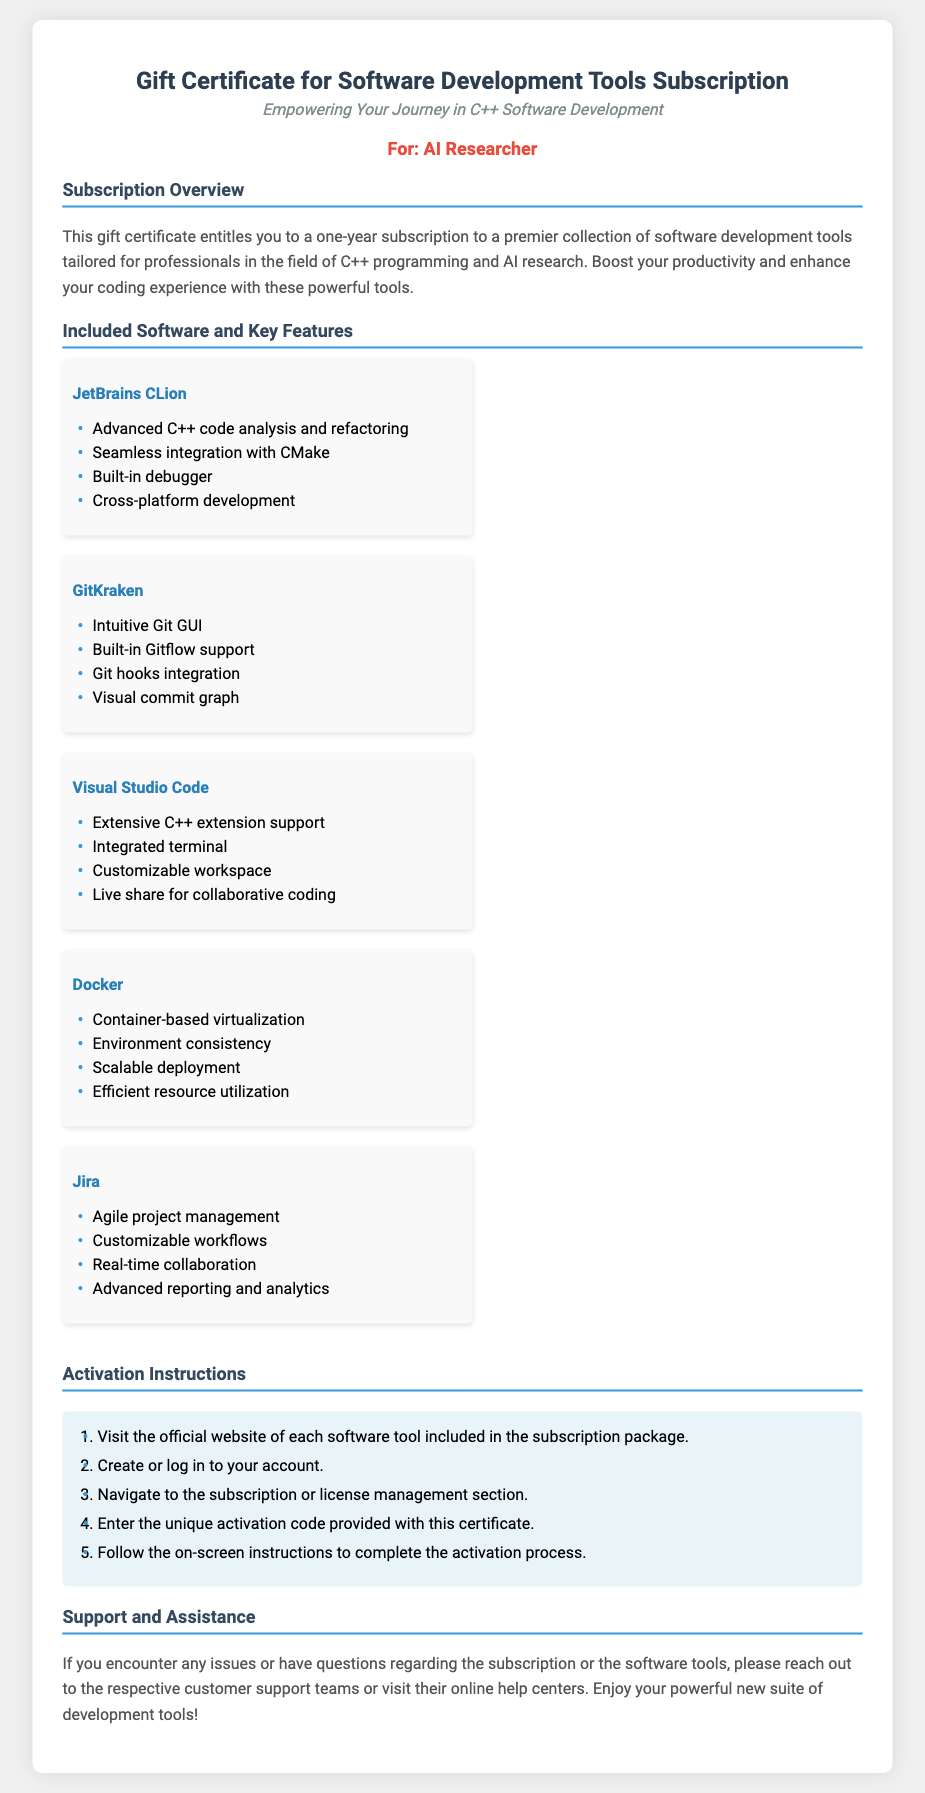What is the title of the document? The title of the document is explicitly mentioned at the top of the certificate, indicating its purpose.
Answer: Gift Certificate for Software Development Tools Subscription Who is the recipient of the gift certificate? The recipient is specifically stated in the document to highlight the intended individual for the gift.
Answer: AI Researcher How many software tools are included in the subscription? The document lists five software tools under the Included Software section, providing a clear count.
Answer: Five What feature does JetBrains CLion provide? Each software item includes a specific feature, with JetBrains CLion noted for its advanced capabilities.
Answer: Advanced C++ code analysis and refactoring What is the first activation instruction? The activation instructions are numbered, detailing the steps necessary to activate the subscription.
Answer: Visit the official website of each software tool included in the subscription package What is the main purpose of the document? The primary purpose is highlighted in the overview section, outlining what the recipient will receive.
Answer: A one-year subscription to a premier collection of software development tools 